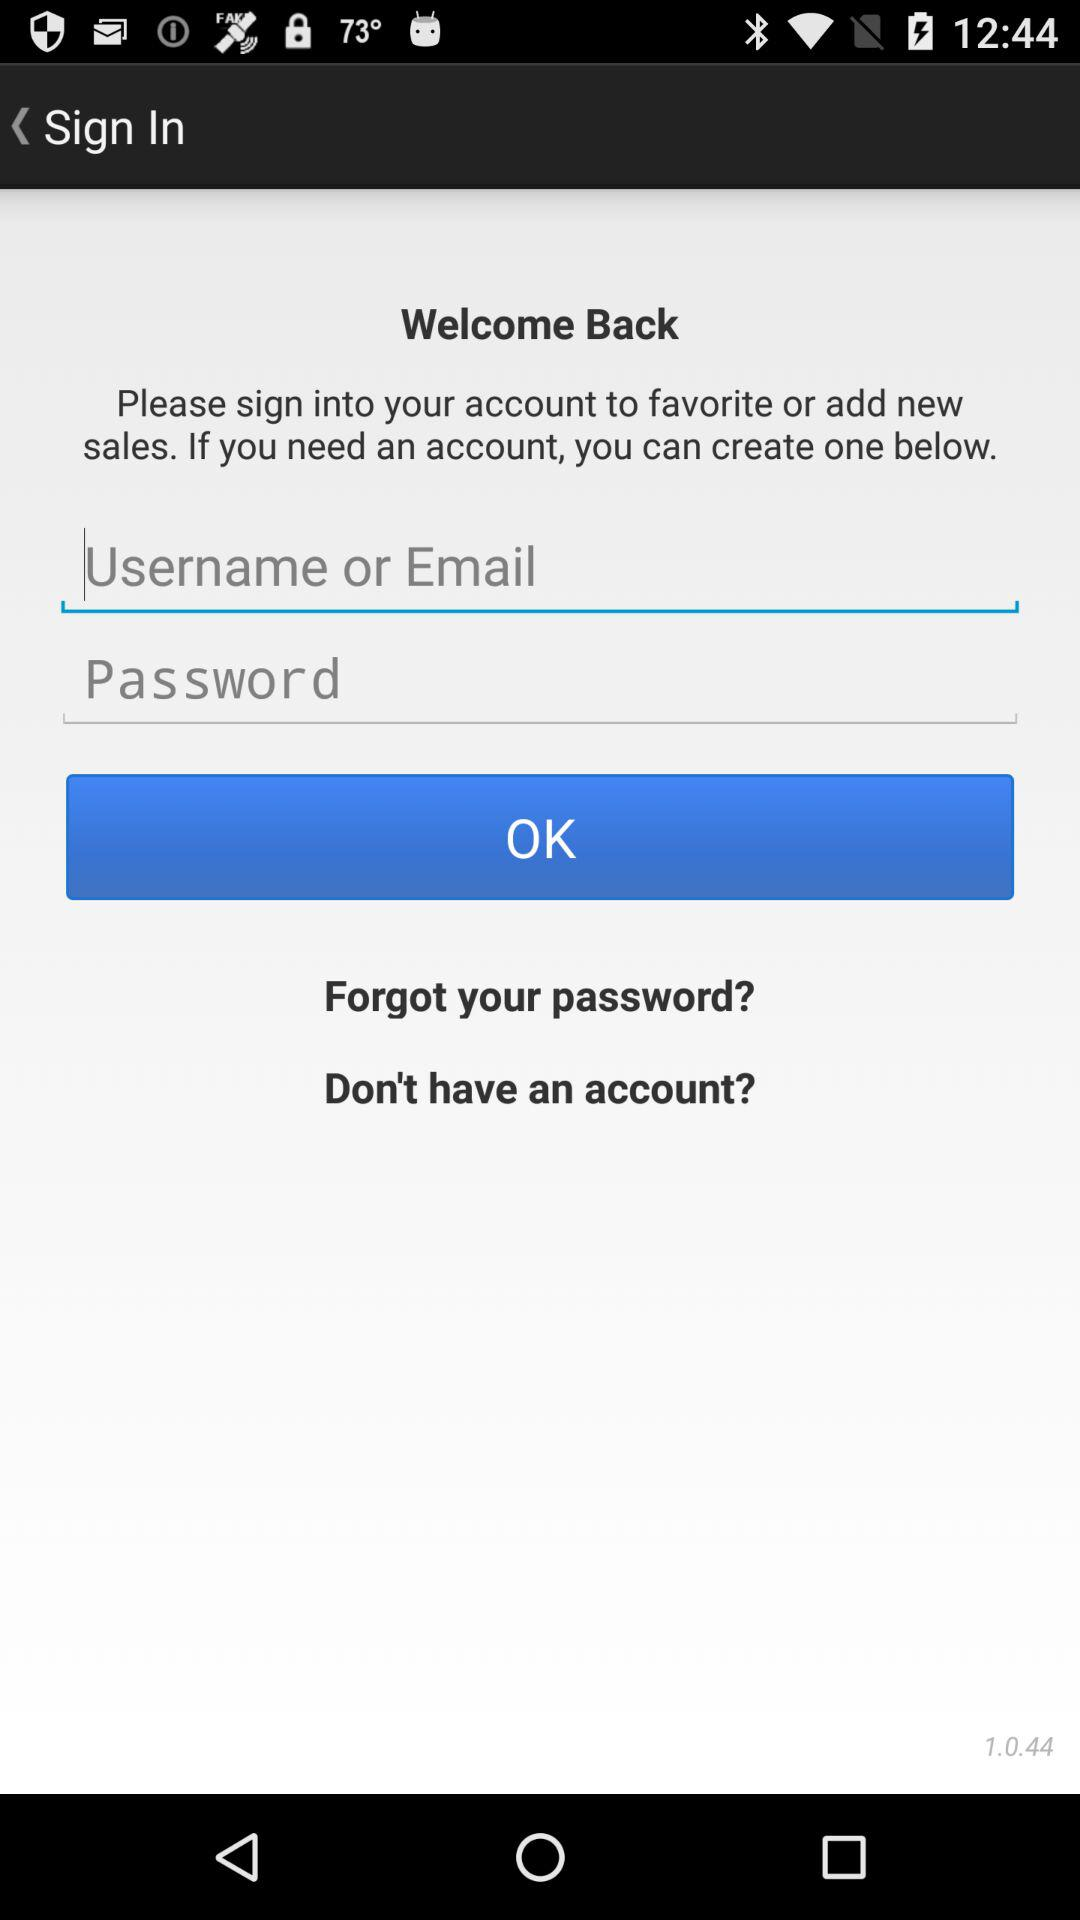How many text inputs are on the screen?
Answer the question using a single word or phrase. 2 